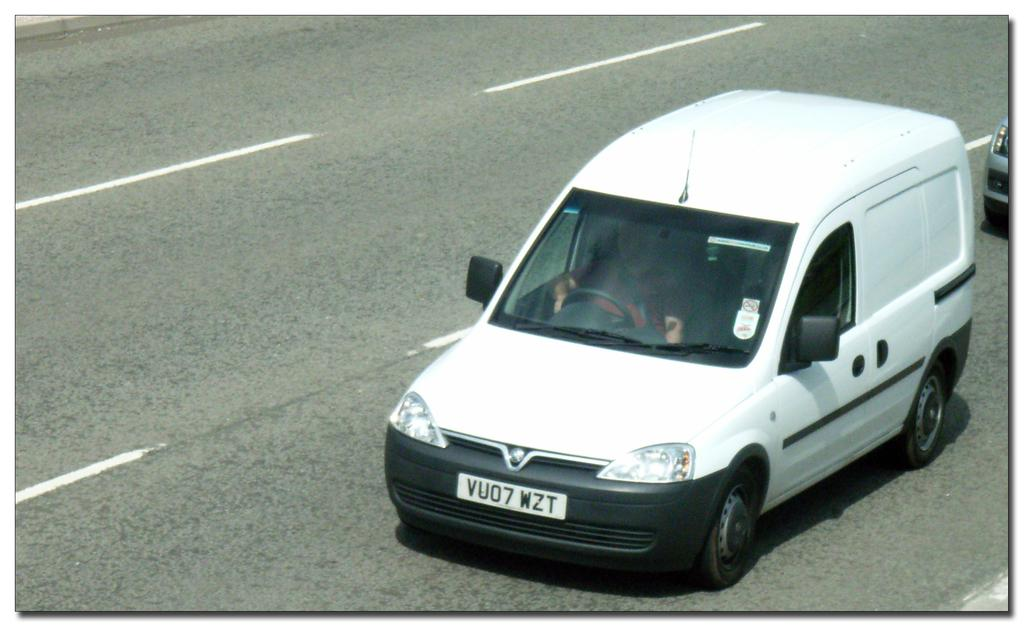How many cars are visible on the road in the image? There are two cars on the road in the image. What other object can be seen in the image besides the cars? There is a fence in the image. Can you tell if the image was taken during the day or night? The image was likely taken during the day, as there is no indication of darkness or artificial lighting. What type of furniture can be seen in the image? There is no furniture present in the image. What time of day is it in the image, specifically in the afternoon? The time of day cannot be determined with certainty, but the image was likely taken during the day, not specifically in the afternoon. 